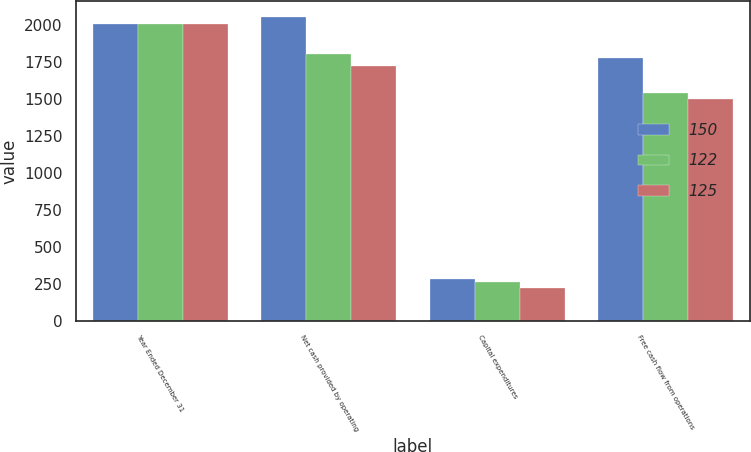Convert chart. <chart><loc_0><loc_0><loc_500><loc_500><stacked_bar_chart><ecel><fcel>Year Ended December 31<fcel>Net cash provided by operating<fcel>Capital expenditures<fcel>Free cash flow from operations<nl><fcel>150<fcel>2005<fcel>2056<fcel>279<fcel>1777<nl><fcel>122<fcel>2004<fcel>1800<fcel>264<fcel>1536<nl><fcel>125<fcel>2003<fcel>1721<fcel>220<fcel>1501<nl></chart> 